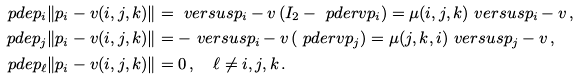Convert formula to latex. <formula><loc_0><loc_0><loc_500><loc_500>\ p d e { p _ { i } } \| p _ { i } - v ( i , j , k ) \| & = \ v e r s u s { p _ { i } - v } \left ( I _ { 2 } - \ p d e r { v } { p _ { i } } \right ) = \mu ( i , j , k ) \ v e r s u s { p _ { i } - v } \, , \\ \ p d e { p _ { j } } \| p _ { i } - v ( i , j , k ) \| & = - \ v e r s u s { p _ { i } - v } \left ( \ p d e r { v } { p _ { j } } \right ) = \mu ( j , k , i ) \ v e r s u s { p _ { j } - v } \, , \\ \ p d e { p _ { \ell } } \| p _ { i } - v ( i , j , k ) \| & = 0 \, , \quad \ell \not = i , j , k \, .</formula> 